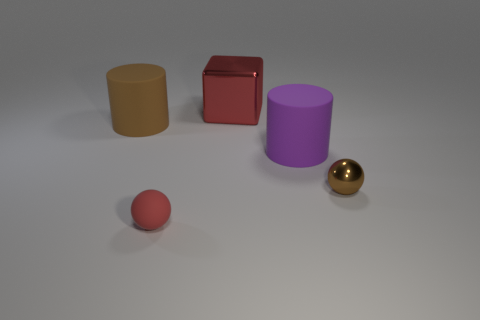Add 1 rubber balls. How many objects exist? 6 Subtract all brown balls. How many balls are left? 1 Add 5 large cubes. How many large cubes are left? 6 Add 3 big cyan shiny balls. How many big cyan shiny balls exist? 3 Subtract 0 brown blocks. How many objects are left? 5 Subtract all cylinders. How many objects are left? 3 Subtract all cyan cubes. Subtract all cyan spheres. How many cubes are left? 1 Subtract all tiny gray rubber cylinders. Subtract all big matte cylinders. How many objects are left? 3 